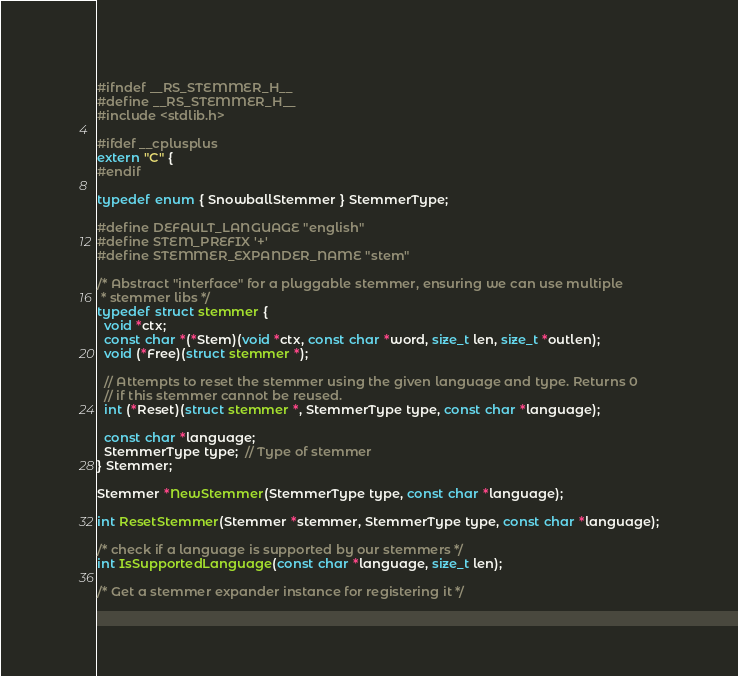<code> <loc_0><loc_0><loc_500><loc_500><_C_>#ifndef __RS_STEMMER_H__
#define __RS_STEMMER_H__
#include <stdlib.h>

#ifdef __cplusplus
extern "C" {
#endif

typedef enum { SnowballStemmer } StemmerType;

#define DEFAULT_LANGUAGE "english"
#define STEM_PREFIX '+'
#define STEMMER_EXPANDER_NAME "stem"

/* Abstract "interface" for a pluggable stemmer, ensuring we can use multiple
 * stemmer libs */
typedef struct stemmer {
  void *ctx;
  const char *(*Stem)(void *ctx, const char *word, size_t len, size_t *outlen);
  void (*Free)(struct stemmer *);

  // Attempts to reset the stemmer using the given language and type. Returns 0
  // if this stemmer cannot be reused.
  int (*Reset)(struct stemmer *, StemmerType type, const char *language);

  const char *language;
  StemmerType type;  // Type of stemmer
} Stemmer;

Stemmer *NewStemmer(StemmerType type, const char *language);

int ResetStemmer(Stemmer *stemmer, StemmerType type, const char *language);

/* check if a language is supported by our stemmers */
int IsSupportedLanguage(const char *language, size_t len);

/* Get a stemmer expander instance for registering it */</code> 